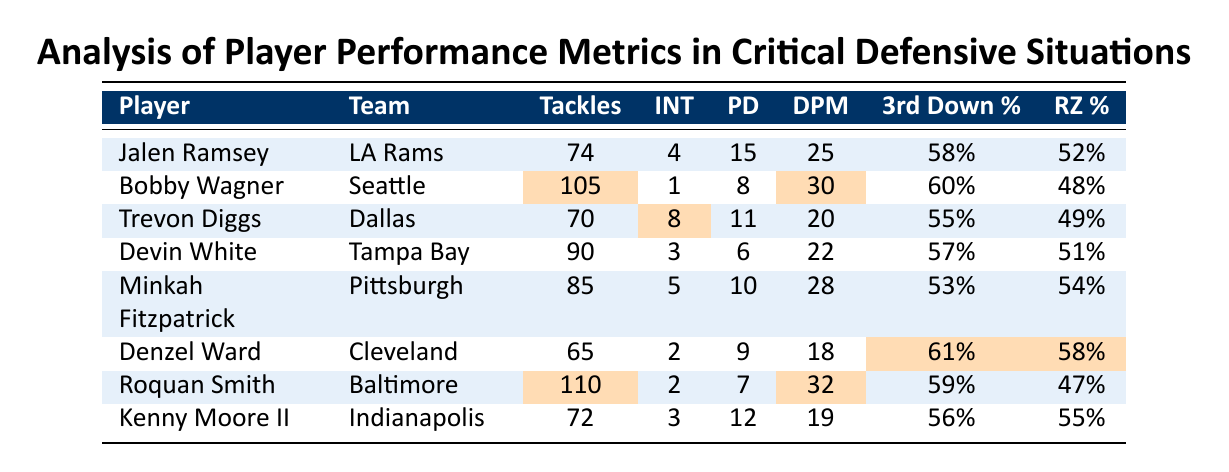What player has the highest number of tackles? By examining the "Tackles" column, Bobby Wagner has the highest number with 105 tackles.
Answer: 105 Which player recorded the most interceptions? Looking at the "INT" column, Trevon Diggs leads with 8 interceptions.
Answer: 8 What is the average percentage for third-down defense across all players? Adding the third-down percentages (58 + 60 + 55 + 57 + 53 + 61 + 59 + 56) = 419; then dividing by 8 gives an average of 52.375%.
Answer: 52.375% Who has the lowest red zone defense percentage? By reviewing the "RZ %" column, Roquan Smith has the lowest percentage at 47%.
Answer: 47 Which player has the highest number of defensive plays made? Roquan Smith has the highest defensive plays made with 32, as seen in the "DPM" column.
Answer: 32 Is Jalen Ramsey's pass deflection count higher than that of Denzel Ward? Jalen Ramsey has 15 pass deflections while Denzel Ward has 9. Thus, yes, Jalen Ramsey's count is higher.
Answer: Yes What is the total number of interceptions made by all players combined? Summing the interceptions (4 + 1 + 8 + 3 + 5 + 2 + 2 + 3) gives a total of 28 interceptions.
Answer: 28 Which player has the best red zone defense percentage? By examining the "RZ %" column, Minkah Fitzpatrick has the best percentage at 54%.
Answer: 54 If we consider only linebackers, who made the most tackles? Roquan Smith has 110 tackles, while Bobby Wagner has 105, making Roquan Smith the highest for linebackers.
Answer: Roquan Smith What is the difference in third-down defense percentage between Denzel Ward and Bobby Wagner? Taking the percentages (61% - 60%), Denzel Ward's percentage is 1% higher than Bobby Wagner's.
Answer: 1% 